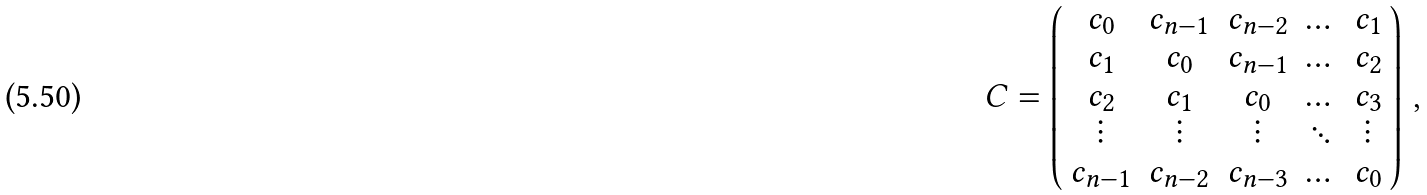Convert formula to latex. <formula><loc_0><loc_0><loc_500><loc_500>C = \left ( \begin{array} { c c c c c } c _ { 0 } & c _ { n - 1 } & c _ { n - 2 } & \dots & c _ { 1 } \\ c _ { 1 } & c _ { 0 } & c _ { n - 1 } & \dots & c _ { 2 } \\ c _ { 2 } & c _ { 1 } & c _ { 0 } & \dots & c _ { 3 } \\ \vdots & \vdots & \vdots & \ddots & \vdots \\ c _ { n - 1 } & c _ { n - 2 } & c _ { n - 3 } & \dots & c _ { 0 } \\ \end{array} \right ) \, ,</formula> 